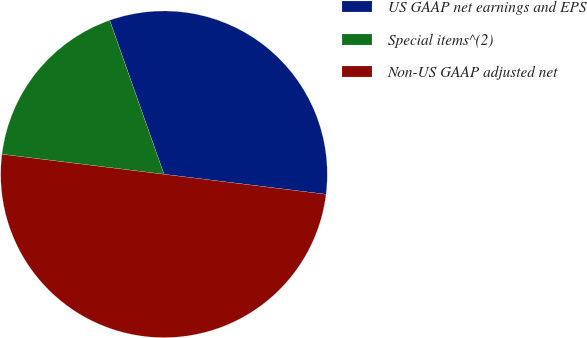Convert chart. <chart><loc_0><loc_0><loc_500><loc_500><pie_chart><fcel>US GAAP net earnings and EPS<fcel>Special items^(2)<fcel>Non-US GAAP adjusted net<nl><fcel>32.35%<fcel>17.65%<fcel>50.0%<nl></chart> 